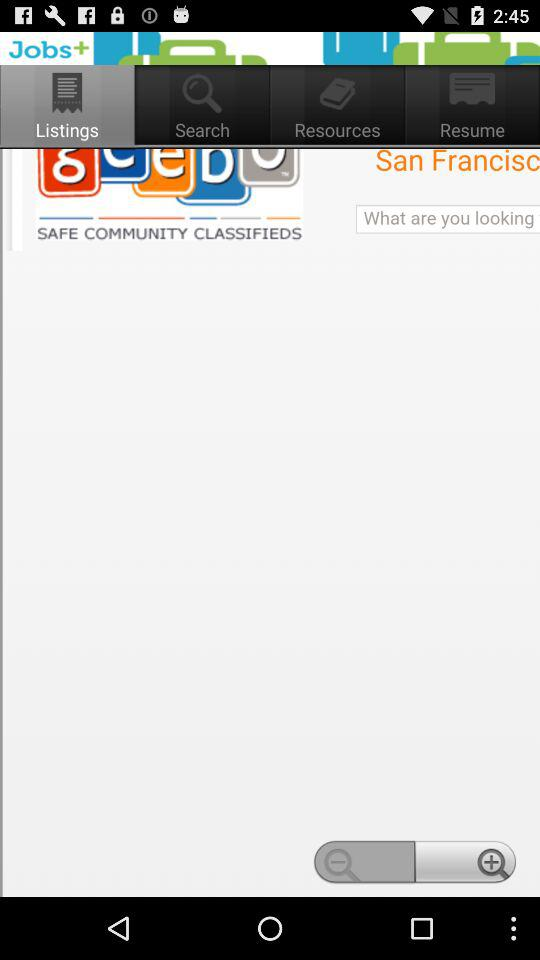Which tab is selected? The selected tab is "Listings". 